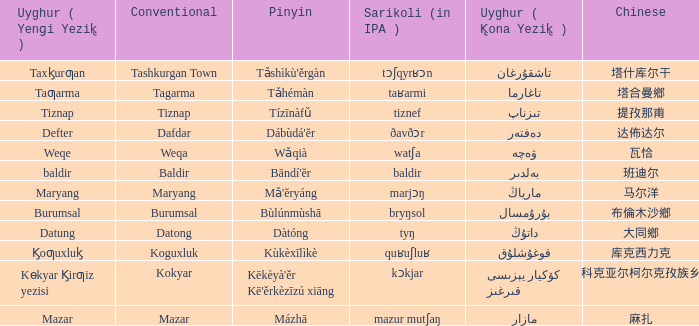Name the pinyin for mazar Mázhā. 